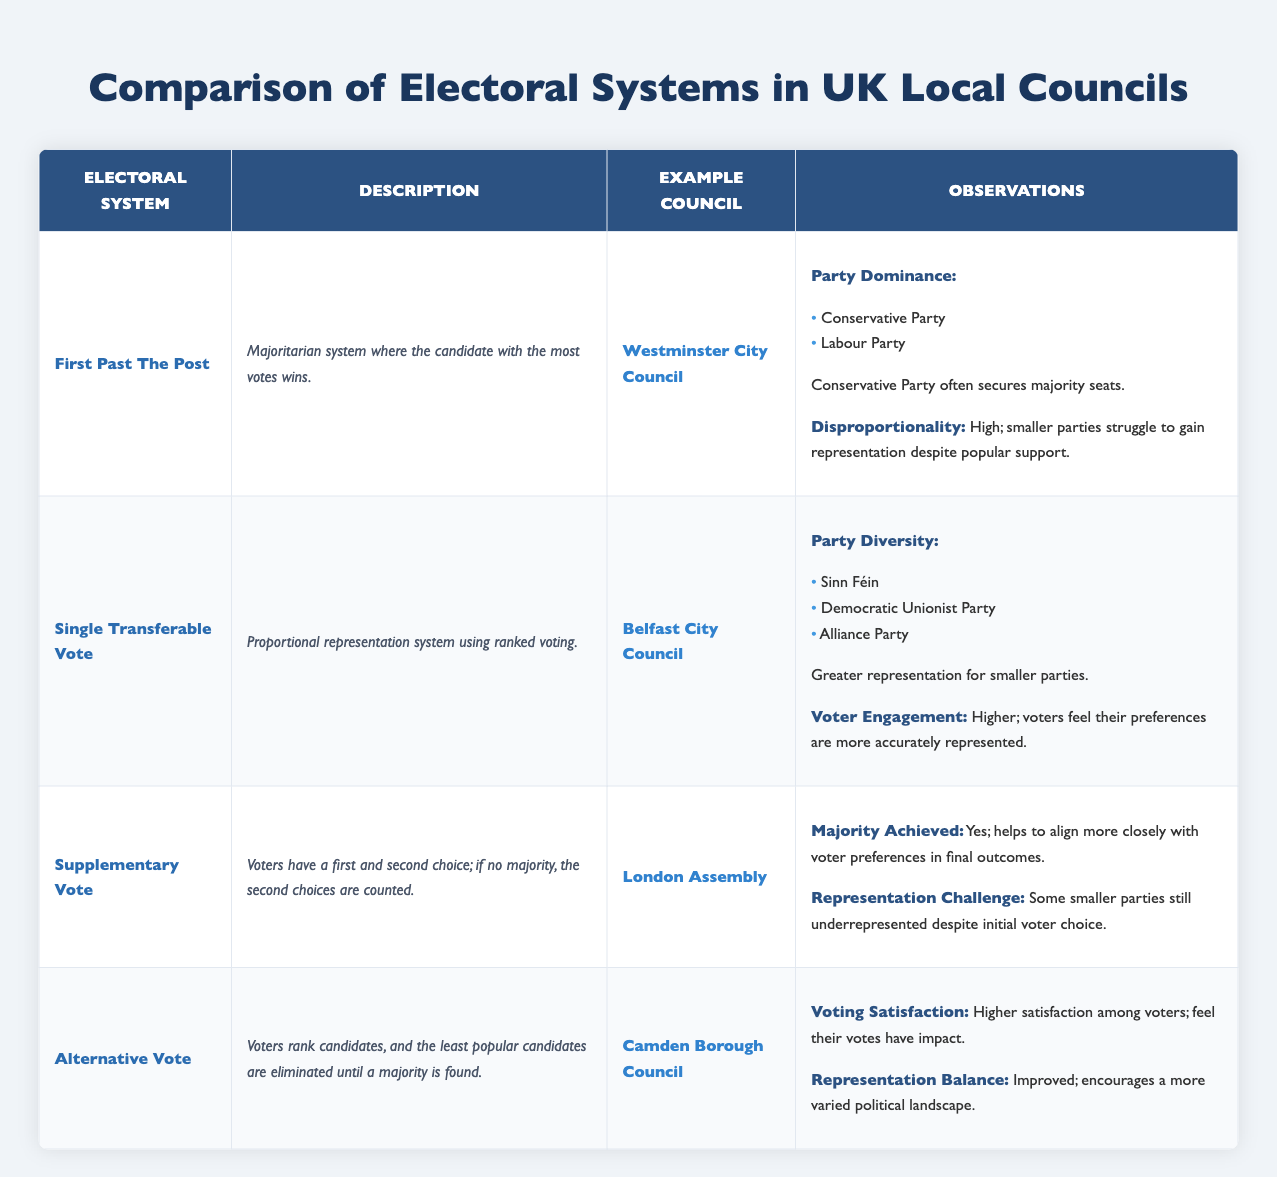What electoral system is used in Westminster City Council? Westminster City Council uses the First Past The Post electoral system, as indicated in the table.
Answer: First Past The Post Which electoral system shows greater representation for smaller parties? The Single Transferable Vote is noted for providing greater representation for smaller parties, specifically in Belfast City Council.
Answer: Single Transferable Vote Does the Supplementary Vote system lead to a majority being achieved? Yes, the table states that the Supplementary Vote system does help achieve a majority, as seen in the London Assembly example.
Answer: Yes How many councils are used as examples for each electoral system? There are four electoral systems listed, each with one corresponding example council, resulting in a total of four councils used as examples.
Answer: Four Which parties dominate in Westminster City Council under the First Past The Post system? The Conservative Party and the Labour Party are the two dominant parties in Westminster City Council, according to the observations section for First Past The Post.
Answer: Conservative Party, Labour Party What is the impact on voter engagement in councils using the Single Transferable Vote? The table indicates higher voter engagement where the Single Transferable Vote is used, as voters feel their preferences are more accurately represented.
Answer: Higher Which electoral system has improved representation balance according to the observations? The Alternative Vote has improved representation balance as indicated in Camden Borough Council, encouraging a more varied political landscape.
Answer: Alternative Vote Under which electoral system is there a representation challenge despite initial voter choice? The Supplementary Vote system faces representation challenges, as the table notes that some smaller parties may still be underrepresented.
Answer: Supplementary Vote In terms of overall satisfaction among voters, which electoral system is noted for higher satisfaction? The Alternative Vote system is associated with higher voter satisfaction as indicated for Camden Borough Council, where voters feel their votes have an impact.
Answer: Alternative Vote 